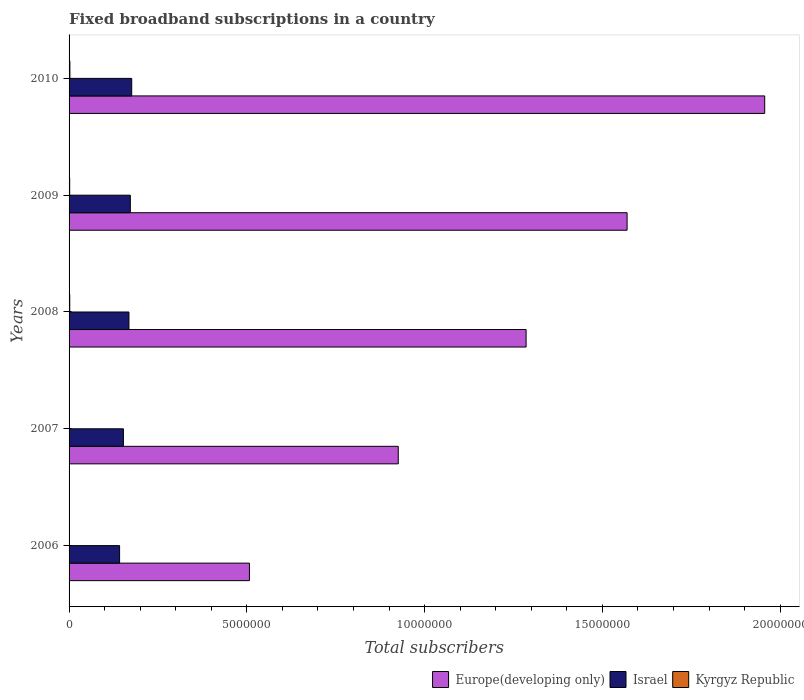How many groups of bars are there?
Keep it short and to the point. 5. In how many cases, is the number of bars for a given year not equal to the number of legend labels?
Make the answer very short. 0. What is the number of broadband subscriptions in Israel in 2007?
Offer a terse response. 1.53e+06. Across all years, what is the maximum number of broadband subscriptions in Israel?
Your answer should be very brief. 1.76e+06. Across all years, what is the minimum number of broadband subscriptions in Israel?
Keep it short and to the point. 1.42e+06. In which year was the number of broadband subscriptions in Israel maximum?
Ensure brevity in your answer.  2010. What is the total number of broadband subscriptions in Europe(developing only) in the graph?
Give a very brief answer. 6.24e+07. What is the difference between the number of broadband subscriptions in Kyrgyz Republic in 2007 and that in 2010?
Provide a short and direct response. -1.99e+04. What is the difference between the number of broadband subscriptions in Kyrgyz Republic in 2010 and the number of broadband subscriptions in Israel in 2006?
Your answer should be very brief. -1.40e+06. What is the average number of broadband subscriptions in Israel per year?
Your answer should be very brief. 1.62e+06. In the year 2008, what is the difference between the number of broadband subscriptions in Kyrgyz Republic and number of broadband subscriptions in Israel?
Offer a terse response. -1.66e+06. What is the ratio of the number of broadband subscriptions in Israel in 2006 to that in 2008?
Offer a terse response. 0.84. Is the number of broadband subscriptions in Europe(developing only) in 2008 less than that in 2009?
Your answer should be compact. Yes. What is the difference between the highest and the second highest number of broadband subscriptions in Europe(developing only)?
Offer a very short reply. 3.87e+06. What is the difference between the highest and the lowest number of broadband subscriptions in Kyrgyz Republic?
Your answer should be compact. 2.03e+04. In how many years, is the number of broadband subscriptions in Europe(developing only) greater than the average number of broadband subscriptions in Europe(developing only) taken over all years?
Provide a succinct answer. 3. Is the sum of the number of broadband subscriptions in Kyrgyz Republic in 2007 and 2009 greater than the maximum number of broadband subscriptions in Israel across all years?
Offer a terse response. No. What does the 1st bar from the bottom in 2010 represents?
Offer a very short reply. Europe(developing only). Is it the case that in every year, the sum of the number of broadband subscriptions in Israel and number of broadband subscriptions in Europe(developing only) is greater than the number of broadband subscriptions in Kyrgyz Republic?
Offer a terse response. Yes. Are all the bars in the graph horizontal?
Ensure brevity in your answer.  Yes. What is the difference between two consecutive major ticks on the X-axis?
Offer a terse response. 5.00e+06. Are the values on the major ticks of X-axis written in scientific E-notation?
Your response must be concise. No. Does the graph contain any zero values?
Make the answer very short. No. Where does the legend appear in the graph?
Your response must be concise. Bottom right. What is the title of the graph?
Provide a short and direct response. Fixed broadband subscriptions in a country. Does "Middle income" appear as one of the legend labels in the graph?
Offer a terse response. No. What is the label or title of the X-axis?
Your answer should be compact. Total subscribers. What is the Total subscribers of Europe(developing only) in 2006?
Your response must be concise. 5.07e+06. What is the Total subscribers in Israel in 2006?
Offer a terse response. 1.42e+06. What is the Total subscribers of Kyrgyz Republic in 2006?
Offer a terse response. 2762. What is the Total subscribers of Europe(developing only) in 2007?
Offer a terse response. 9.26e+06. What is the Total subscribers in Israel in 2007?
Offer a terse response. 1.53e+06. What is the Total subscribers of Kyrgyz Republic in 2007?
Ensure brevity in your answer.  3115. What is the Total subscribers of Europe(developing only) in 2008?
Your response must be concise. 1.29e+07. What is the Total subscribers of Israel in 2008?
Keep it short and to the point. 1.68e+06. What is the Total subscribers of Kyrgyz Republic in 2008?
Offer a terse response. 1.90e+04. What is the Total subscribers in Europe(developing only) in 2009?
Offer a terse response. 1.57e+07. What is the Total subscribers of Israel in 2009?
Make the answer very short. 1.72e+06. What is the Total subscribers of Kyrgyz Republic in 2009?
Keep it short and to the point. 1.74e+04. What is the Total subscribers of Europe(developing only) in 2010?
Provide a succinct answer. 1.96e+07. What is the Total subscribers in Israel in 2010?
Your response must be concise. 1.76e+06. What is the Total subscribers of Kyrgyz Republic in 2010?
Provide a short and direct response. 2.31e+04. Across all years, what is the maximum Total subscribers in Europe(developing only)?
Offer a terse response. 1.96e+07. Across all years, what is the maximum Total subscribers in Israel?
Make the answer very short. 1.76e+06. Across all years, what is the maximum Total subscribers in Kyrgyz Republic?
Your answer should be compact. 2.31e+04. Across all years, what is the minimum Total subscribers in Europe(developing only)?
Your response must be concise. 5.07e+06. Across all years, what is the minimum Total subscribers in Israel?
Provide a short and direct response. 1.42e+06. Across all years, what is the minimum Total subscribers in Kyrgyz Republic?
Offer a very short reply. 2762. What is the total Total subscribers in Europe(developing only) in the graph?
Give a very brief answer. 6.24e+07. What is the total Total subscribers in Israel in the graph?
Offer a very short reply. 8.12e+06. What is the total Total subscribers in Kyrgyz Republic in the graph?
Provide a succinct answer. 6.53e+04. What is the difference between the Total subscribers of Europe(developing only) in 2006 and that in 2007?
Give a very brief answer. -4.19e+06. What is the difference between the Total subscribers in Israel in 2006 and that in 2007?
Provide a succinct answer. -1.08e+05. What is the difference between the Total subscribers in Kyrgyz Republic in 2006 and that in 2007?
Your response must be concise. -353. What is the difference between the Total subscribers of Europe(developing only) in 2006 and that in 2008?
Keep it short and to the point. -7.78e+06. What is the difference between the Total subscribers of Israel in 2006 and that in 2008?
Keep it short and to the point. -2.63e+05. What is the difference between the Total subscribers in Kyrgyz Republic in 2006 and that in 2008?
Your answer should be very brief. -1.63e+04. What is the difference between the Total subscribers of Europe(developing only) in 2006 and that in 2009?
Your response must be concise. -1.06e+07. What is the difference between the Total subscribers of Israel in 2006 and that in 2009?
Provide a succinct answer. -3.02e+05. What is the difference between the Total subscribers of Kyrgyz Republic in 2006 and that in 2009?
Provide a succinct answer. -1.46e+04. What is the difference between the Total subscribers in Europe(developing only) in 2006 and that in 2010?
Your answer should be compact. -1.45e+07. What is the difference between the Total subscribers in Israel in 2006 and that in 2010?
Your response must be concise. -3.41e+05. What is the difference between the Total subscribers in Kyrgyz Republic in 2006 and that in 2010?
Keep it short and to the point. -2.03e+04. What is the difference between the Total subscribers in Europe(developing only) in 2007 and that in 2008?
Offer a terse response. -3.60e+06. What is the difference between the Total subscribers in Israel in 2007 and that in 2008?
Your answer should be compact. -1.56e+05. What is the difference between the Total subscribers of Kyrgyz Republic in 2007 and that in 2008?
Offer a terse response. -1.59e+04. What is the difference between the Total subscribers in Europe(developing only) in 2007 and that in 2009?
Make the answer very short. -6.44e+06. What is the difference between the Total subscribers in Israel in 2007 and that in 2009?
Make the answer very short. -1.94e+05. What is the difference between the Total subscribers in Kyrgyz Republic in 2007 and that in 2009?
Provide a succinct answer. -1.42e+04. What is the difference between the Total subscribers of Europe(developing only) in 2007 and that in 2010?
Keep it short and to the point. -1.03e+07. What is the difference between the Total subscribers of Israel in 2007 and that in 2010?
Your answer should be compact. -2.34e+05. What is the difference between the Total subscribers of Kyrgyz Republic in 2007 and that in 2010?
Offer a very short reply. -1.99e+04. What is the difference between the Total subscribers of Europe(developing only) in 2008 and that in 2009?
Make the answer very short. -2.84e+06. What is the difference between the Total subscribers of Israel in 2008 and that in 2009?
Provide a short and direct response. -3.90e+04. What is the difference between the Total subscribers in Kyrgyz Republic in 2008 and that in 2009?
Give a very brief answer. 1677. What is the difference between the Total subscribers of Europe(developing only) in 2008 and that in 2010?
Keep it short and to the point. -6.71e+06. What is the difference between the Total subscribers of Israel in 2008 and that in 2010?
Make the answer very short. -7.80e+04. What is the difference between the Total subscribers in Kyrgyz Republic in 2008 and that in 2010?
Keep it short and to the point. -4021. What is the difference between the Total subscribers of Europe(developing only) in 2009 and that in 2010?
Your answer should be very brief. -3.87e+06. What is the difference between the Total subscribers in Israel in 2009 and that in 2010?
Provide a succinct answer. -3.90e+04. What is the difference between the Total subscribers of Kyrgyz Republic in 2009 and that in 2010?
Offer a very short reply. -5698. What is the difference between the Total subscribers in Europe(developing only) in 2006 and the Total subscribers in Israel in 2007?
Keep it short and to the point. 3.54e+06. What is the difference between the Total subscribers in Europe(developing only) in 2006 and the Total subscribers in Kyrgyz Republic in 2007?
Provide a succinct answer. 5.07e+06. What is the difference between the Total subscribers in Israel in 2006 and the Total subscribers in Kyrgyz Republic in 2007?
Provide a succinct answer. 1.42e+06. What is the difference between the Total subscribers in Europe(developing only) in 2006 and the Total subscribers in Israel in 2008?
Offer a terse response. 3.39e+06. What is the difference between the Total subscribers of Europe(developing only) in 2006 and the Total subscribers of Kyrgyz Republic in 2008?
Ensure brevity in your answer.  5.05e+06. What is the difference between the Total subscribers in Israel in 2006 and the Total subscribers in Kyrgyz Republic in 2008?
Provide a short and direct response. 1.40e+06. What is the difference between the Total subscribers in Europe(developing only) in 2006 and the Total subscribers in Israel in 2009?
Your response must be concise. 3.35e+06. What is the difference between the Total subscribers of Europe(developing only) in 2006 and the Total subscribers of Kyrgyz Republic in 2009?
Make the answer very short. 5.06e+06. What is the difference between the Total subscribers of Israel in 2006 and the Total subscribers of Kyrgyz Republic in 2009?
Provide a short and direct response. 1.40e+06. What is the difference between the Total subscribers of Europe(developing only) in 2006 and the Total subscribers of Israel in 2010?
Make the answer very short. 3.31e+06. What is the difference between the Total subscribers in Europe(developing only) in 2006 and the Total subscribers in Kyrgyz Republic in 2010?
Provide a short and direct response. 5.05e+06. What is the difference between the Total subscribers in Israel in 2006 and the Total subscribers in Kyrgyz Republic in 2010?
Keep it short and to the point. 1.40e+06. What is the difference between the Total subscribers in Europe(developing only) in 2007 and the Total subscribers in Israel in 2008?
Keep it short and to the point. 7.57e+06. What is the difference between the Total subscribers of Europe(developing only) in 2007 and the Total subscribers of Kyrgyz Republic in 2008?
Make the answer very short. 9.24e+06. What is the difference between the Total subscribers of Israel in 2007 and the Total subscribers of Kyrgyz Republic in 2008?
Keep it short and to the point. 1.51e+06. What is the difference between the Total subscribers in Europe(developing only) in 2007 and the Total subscribers in Israel in 2009?
Offer a very short reply. 7.53e+06. What is the difference between the Total subscribers of Europe(developing only) in 2007 and the Total subscribers of Kyrgyz Republic in 2009?
Offer a very short reply. 9.24e+06. What is the difference between the Total subscribers of Israel in 2007 and the Total subscribers of Kyrgyz Republic in 2009?
Offer a very short reply. 1.51e+06. What is the difference between the Total subscribers in Europe(developing only) in 2007 and the Total subscribers in Israel in 2010?
Offer a very short reply. 7.50e+06. What is the difference between the Total subscribers of Europe(developing only) in 2007 and the Total subscribers of Kyrgyz Republic in 2010?
Your response must be concise. 9.23e+06. What is the difference between the Total subscribers of Israel in 2007 and the Total subscribers of Kyrgyz Republic in 2010?
Your answer should be very brief. 1.51e+06. What is the difference between the Total subscribers of Europe(developing only) in 2008 and the Total subscribers of Israel in 2009?
Give a very brief answer. 1.11e+07. What is the difference between the Total subscribers in Europe(developing only) in 2008 and the Total subscribers in Kyrgyz Republic in 2009?
Your response must be concise. 1.28e+07. What is the difference between the Total subscribers in Israel in 2008 and the Total subscribers in Kyrgyz Republic in 2009?
Offer a very short reply. 1.67e+06. What is the difference between the Total subscribers of Europe(developing only) in 2008 and the Total subscribers of Israel in 2010?
Make the answer very short. 1.11e+07. What is the difference between the Total subscribers in Europe(developing only) in 2008 and the Total subscribers in Kyrgyz Republic in 2010?
Your answer should be very brief. 1.28e+07. What is the difference between the Total subscribers in Israel in 2008 and the Total subscribers in Kyrgyz Republic in 2010?
Provide a short and direct response. 1.66e+06. What is the difference between the Total subscribers in Europe(developing only) in 2009 and the Total subscribers in Israel in 2010?
Your answer should be very brief. 1.39e+07. What is the difference between the Total subscribers of Europe(developing only) in 2009 and the Total subscribers of Kyrgyz Republic in 2010?
Give a very brief answer. 1.57e+07. What is the difference between the Total subscribers of Israel in 2009 and the Total subscribers of Kyrgyz Republic in 2010?
Your response must be concise. 1.70e+06. What is the average Total subscribers in Europe(developing only) per year?
Offer a terse response. 1.25e+07. What is the average Total subscribers in Israel per year?
Provide a succinct answer. 1.62e+06. What is the average Total subscribers in Kyrgyz Republic per year?
Your answer should be very brief. 1.31e+04. In the year 2006, what is the difference between the Total subscribers in Europe(developing only) and Total subscribers in Israel?
Your answer should be very brief. 3.65e+06. In the year 2006, what is the difference between the Total subscribers of Europe(developing only) and Total subscribers of Kyrgyz Republic?
Offer a very short reply. 5.07e+06. In the year 2006, what is the difference between the Total subscribers in Israel and Total subscribers in Kyrgyz Republic?
Offer a very short reply. 1.42e+06. In the year 2007, what is the difference between the Total subscribers of Europe(developing only) and Total subscribers of Israel?
Keep it short and to the point. 7.73e+06. In the year 2007, what is the difference between the Total subscribers in Europe(developing only) and Total subscribers in Kyrgyz Republic?
Keep it short and to the point. 9.25e+06. In the year 2007, what is the difference between the Total subscribers in Israel and Total subscribers in Kyrgyz Republic?
Keep it short and to the point. 1.53e+06. In the year 2008, what is the difference between the Total subscribers of Europe(developing only) and Total subscribers of Israel?
Give a very brief answer. 1.12e+07. In the year 2008, what is the difference between the Total subscribers in Europe(developing only) and Total subscribers in Kyrgyz Republic?
Your answer should be very brief. 1.28e+07. In the year 2008, what is the difference between the Total subscribers of Israel and Total subscribers of Kyrgyz Republic?
Keep it short and to the point. 1.66e+06. In the year 2009, what is the difference between the Total subscribers of Europe(developing only) and Total subscribers of Israel?
Make the answer very short. 1.40e+07. In the year 2009, what is the difference between the Total subscribers in Europe(developing only) and Total subscribers in Kyrgyz Republic?
Your response must be concise. 1.57e+07. In the year 2009, what is the difference between the Total subscribers in Israel and Total subscribers in Kyrgyz Republic?
Provide a succinct answer. 1.71e+06. In the year 2010, what is the difference between the Total subscribers in Europe(developing only) and Total subscribers in Israel?
Provide a succinct answer. 1.78e+07. In the year 2010, what is the difference between the Total subscribers in Europe(developing only) and Total subscribers in Kyrgyz Republic?
Offer a very short reply. 1.95e+07. In the year 2010, what is the difference between the Total subscribers in Israel and Total subscribers in Kyrgyz Republic?
Provide a succinct answer. 1.74e+06. What is the ratio of the Total subscribers in Europe(developing only) in 2006 to that in 2007?
Offer a terse response. 0.55. What is the ratio of the Total subscribers of Israel in 2006 to that in 2007?
Offer a very short reply. 0.93. What is the ratio of the Total subscribers in Kyrgyz Republic in 2006 to that in 2007?
Provide a succinct answer. 0.89. What is the ratio of the Total subscribers in Europe(developing only) in 2006 to that in 2008?
Provide a succinct answer. 0.39. What is the ratio of the Total subscribers in Israel in 2006 to that in 2008?
Give a very brief answer. 0.84. What is the ratio of the Total subscribers in Kyrgyz Republic in 2006 to that in 2008?
Your answer should be compact. 0.15. What is the ratio of the Total subscribers in Europe(developing only) in 2006 to that in 2009?
Provide a succinct answer. 0.32. What is the ratio of the Total subscribers in Israel in 2006 to that in 2009?
Offer a terse response. 0.82. What is the ratio of the Total subscribers of Kyrgyz Republic in 2006 to that in 2009?
Your answer should be compact. 0.16. What is the ratio of the Total subscribers of Europe(developing only) in 2006 to that in 2010?
Offer a very short reply. 0.26. What is the ratio of the Total subscribers in Israel in 2006 to that in 2010?
Your response must be concise. 0.81. What is the ratio of the Total subscribers of Kyrgyz Republic in 2006 to that in 2010?
Your response must be concise. 0.12. What is the ratio of the Total subscribers in Europe(developing only) in 2007 to that in 2008?
Your answer should be compact. 0.72. What is the ratio of the Total subscribers in Israel in 2007 to that in 2008?
Offer a terse response. 0.91. What is the ratio of the Total subscribers of Kyrgyz Republic in 2007 to that in 2008?
Provide a succinct answer. 0.16. What is the ratio of the Total subscribers in Europe(developing only) in 2007 to that in 2009?
Provide a short and direct response. 0.59. What is the ratio of the Total subscribers of Israel in 2007 to that in 2009?
Give a very brief answer. 0.89. What is the ratio of the Total subscribers of Kyrgyz Republic in 2007 to that in 2009?
Offer a terse response. 0.18. What is the ratio of the Total subscribers in Europe(developing only) in 2007 to that in 2010?
Provide a short and direct response. 0.47. What is the ratio of the Total subscribers in Israel in 2007 to that in 2010?
Offer a very short reply. 0.87. What is the ratio of the Total subscribers of Kyrgyz Republic in 2007 to that in 2010?
Keep it short and to the point. 0.14. What is the ratio of the Total subscribers in Europe(developing only) in 2008 to that in 2009?
Make the answer very short. 0.82. What is the ratio of the Total subscribers of Israel in 2008 to that in 2009?
Offer a very short reply. 0.98. What is the ratio of the Total subscribers of Kyrgyz Republic in 2008 to that in 2009?
Provide a short and direct response. 1.1. What is the ratio of the Total subscribers in Europe(developing only) in 2008 to that in 2010?
Provide a short and direct response. 0.66. What is the ratio of the Total subscribers in Israel in 2008 to that in 2010?
Make the answer very short. 0.96. What is the ratio of the Total subscribers of Kyrgyz Republic in 2008 to that in 2010?
Provide a short and direct response. 0.83. What is the ratio of the Total subscribers in Europe(developing only) in 2009 to that in 2010?
Ensure brevity in your answer.  0.8. What is the ratio of the Total subscribers of Israel in 2009 to that in 2010?
Your response must be concise. 0.98. What is the ratio of the Total subscribers in Kyrgyz Republic in 2009 to that in 2010?
Your answer should be very brief. 0.75. What is the difference between the highest and the second highest Total subscribers in Europe(developing only)?
Give a very brief answer. 3.87e+06. What is the difference between the highest and the second highest Total subscribers in Israel?
Offer a very short reply. 3.90e+04. What is the difference between the highest and the second highest Total subscribers of Kyrgyz Republic?
Provide a succinct answer. 4021. What is the difference between the highest and the lowest Total subscribers of Europe(developing only)?
Your answer should be compact. 1.45e+07. What is the difference between the highest and the lowest Total subscribers in Israel?
Provide a short and direct response. 3.41e+05. What is the difference between the highest and the lowest Total subscribers in Kyrgyz Republic?
Your answer should be compact. 2.03e+04. 